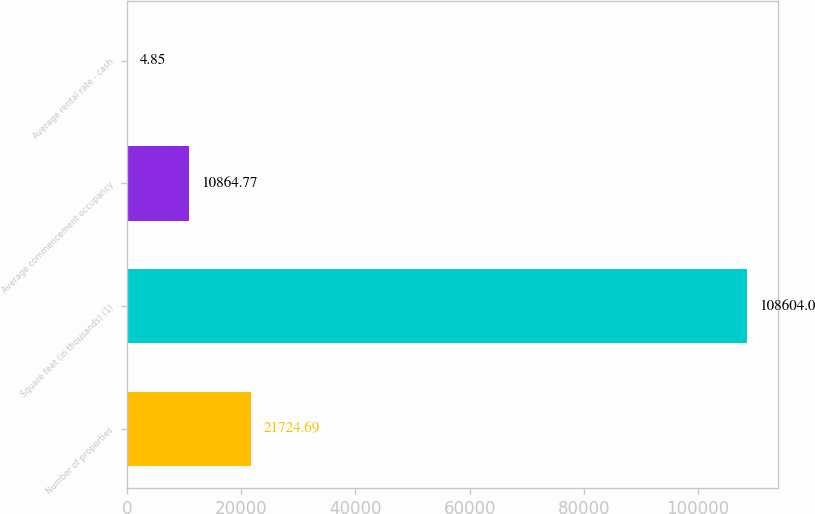Convert chart to OTSL. <chart><loc_0><loc_0><loc_500><loc_500><bar_chart><fcel>Number of properties<fcel>Square feet (in thousands) (1)<fcel>Average commencement occupancy<fcel>Average rental rate - cash<nl><fcel>21724.7<fcel>108604<fcel>10864.8<fcel>4.85<nl></chart> 